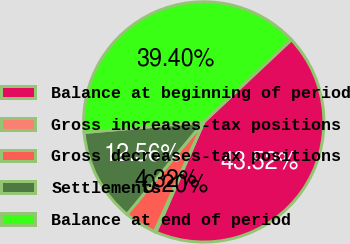Convert chart. <chart><loc_0><loc_0><loc_500><loc_500><pie_chart><fcel>Balance at beginning of period<fcel>Gross increases-tax positions<fcel>Gross decreases-tax positions<fcel>Settlements<fcel>Balance at end of period<nl><fcel>43.52%<fcel>0.2%<fcel>4.32%<fcel>12.56%<fcel>39.4%<nl></chart> 